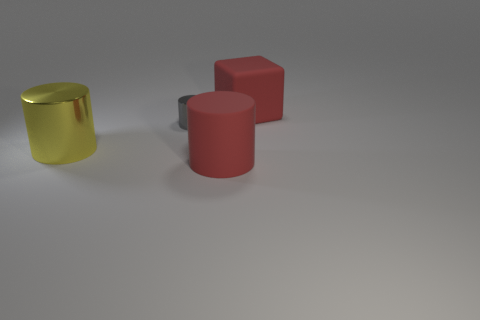Is there anything else that has the same size as the gray shiny cylinder?
Offer a terse response. No. There is a cylinder that is the same color as the cube; what is its size?
Give a very brief answer. Large. There is a matte cube; is its color the same as the large cylinder that is right of the yellow metallic thing?
Offer a very short reply. Yes. How many other things are the same size as the red cylinder?
Ensure brevity in your answer.  2. There is a red rubber cube; is it the same size as the yellow thing behind the matte cylinder?
Make the answer very short. Yes. There is a cylinder that is both to the right of the yellow cylinder and in front of the tiny gray cylinder; what color is it?
Offer a very short reply. Red. How many other things are there of the same shape as the large yellow object?
Your answer should be compact. 2. There is a large object that is behind the big yellow metal cylinder; is it the same color as the large rubber object that is in front of the tiny gray metallic cylinder?
Give a very brief answer. Yes. Do the metallic cylinder left of the gray shiny object and the rubber object in front of the gray shiny cylinder have the same size?
Make the answer very short. Yes. The large thing behind the big cylinder that is to the left of the rubber thing that is in front of the big yellow metal cylinder is made of what material?
Provide a succinct answer. Rubber. 